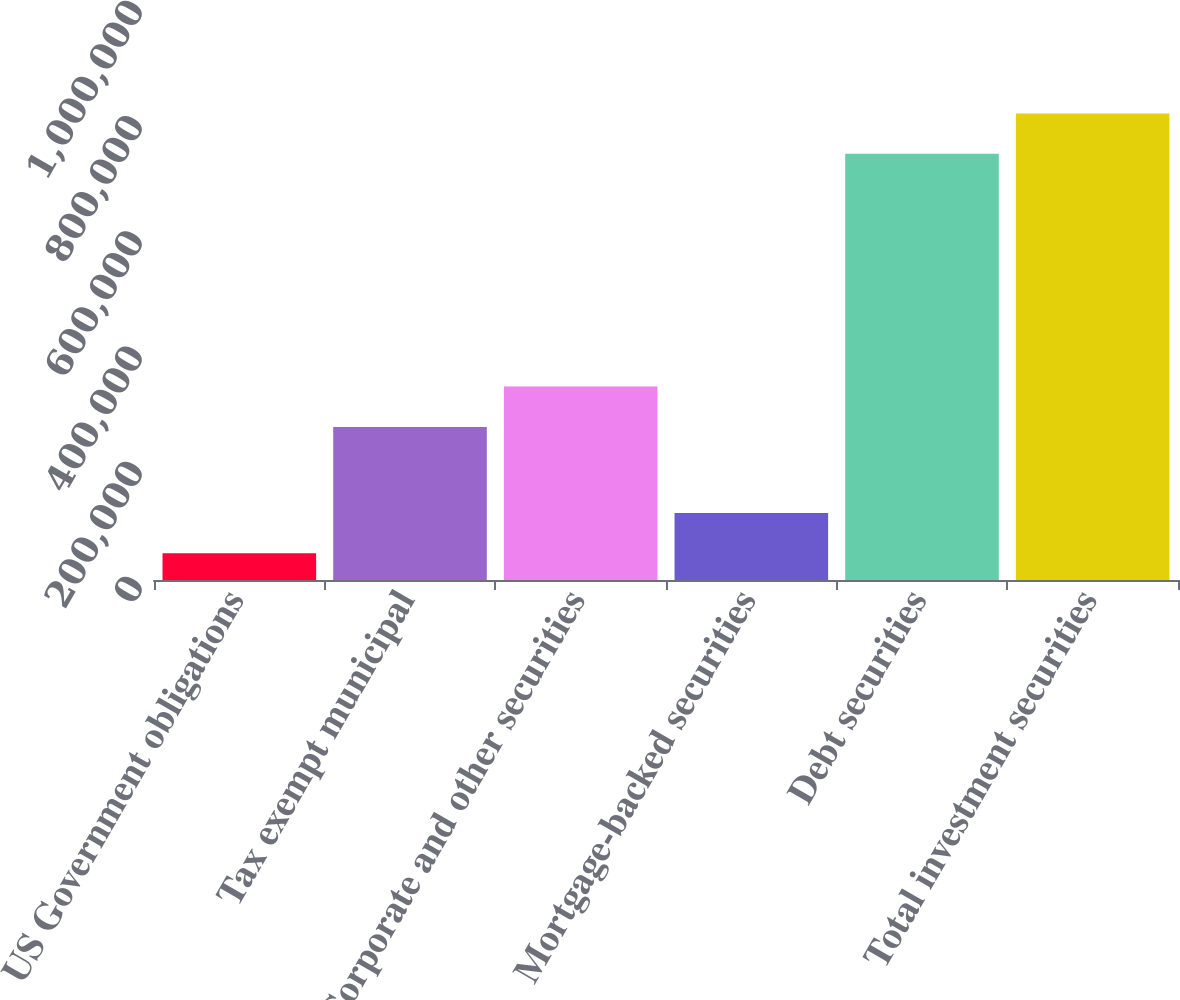Convert chart to OTSL. <chart><loc_0><loc_0><loc_500><loc_500><bar_chart><fcel>US Government obligations<fcel>Tax exempt municipal<fcel>Corporate and other securities<fcel>Mortgage-backed securities<fcel>Debt securities<fcel>Total investment securities<nl><fcel>46272<fcel>265816<fcel>335814<fcel>116270<fcel>739846<fcel>809844<nl></chart> 